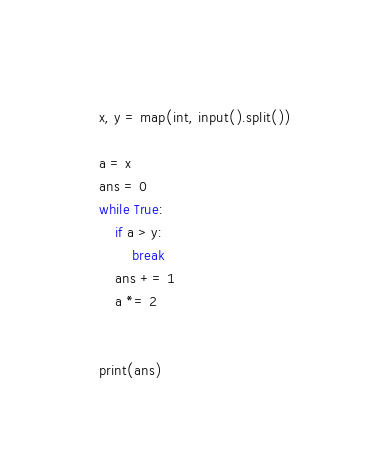<code> <loc_0><loc_0><loc_500><loc_500><_Python_>x, y = map(int, input().split())

a = x
ans = 0
while True:
    if a > y:
        break
    ans += 1
    a *= 2


print(ans)</code> 